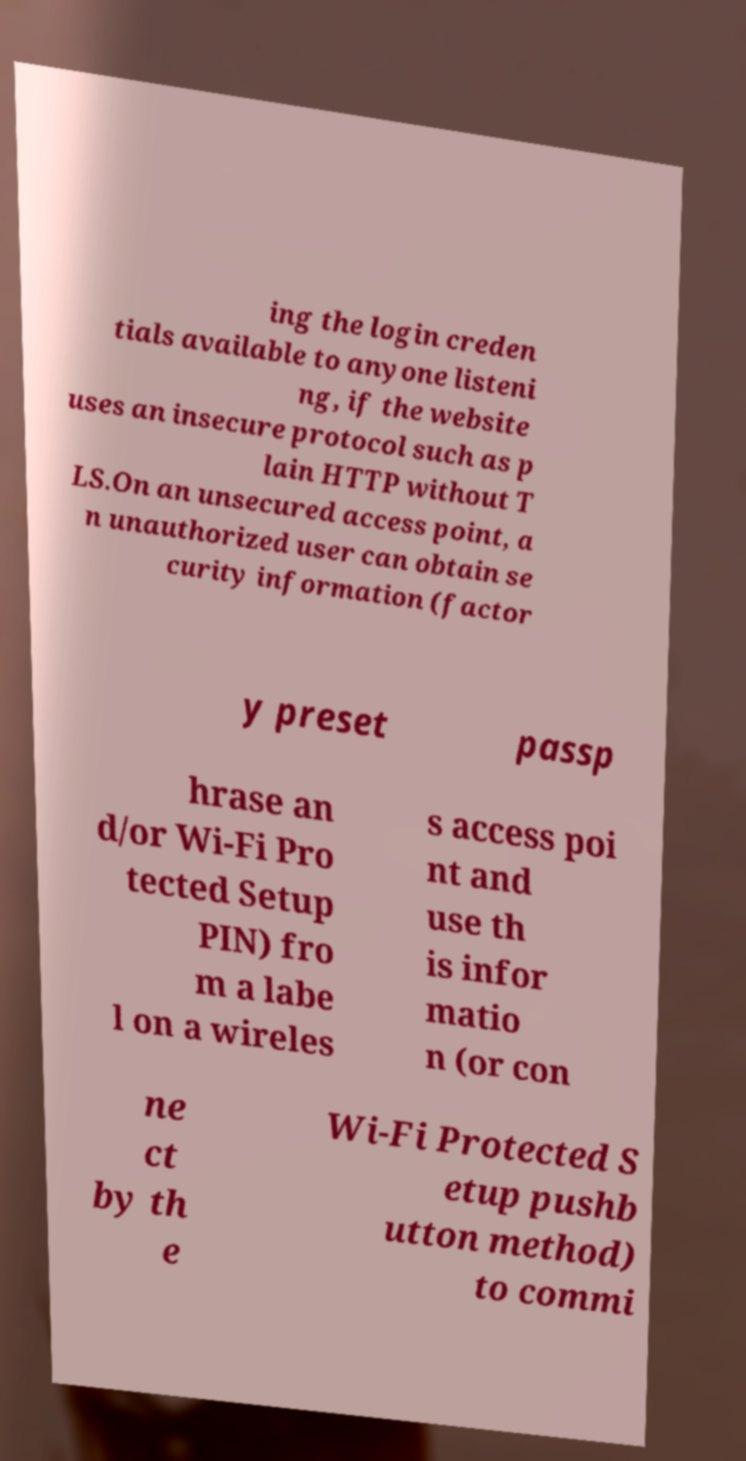Could you extract and type out the text from this image? ing the login creden tials available to anyone listeni ng, if the website uses an insecure protocol such as p lain HTTP without T LS.On an unsecured access point, a n unauthorized user can obtain se curity information (factor y preset passp hrase an d/or Wi-Fi Pro tected Setup PIN) fro m a labe l on a wireles s access poi nt and use th is infor matio n (or con ne ct by th e Wi-Fi Protected S etup pushb utton method) to commi 